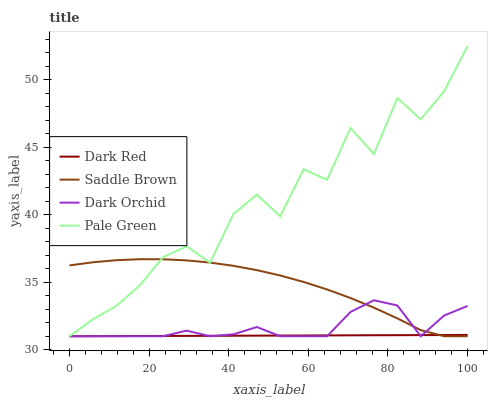Does Saddle Brown have the minimum area under the curve?
Answer yes or no. No. Does Saddle Brown have the maximum area under the curve?
Answer yes or no. No. Is Saddle Brown the smoothest?
Answer yes or no. No. Is Saddle Brown the roughest?
Answer yes or no. No. Does Saddle Brown have the highest value?
Answer yes or no. No. 